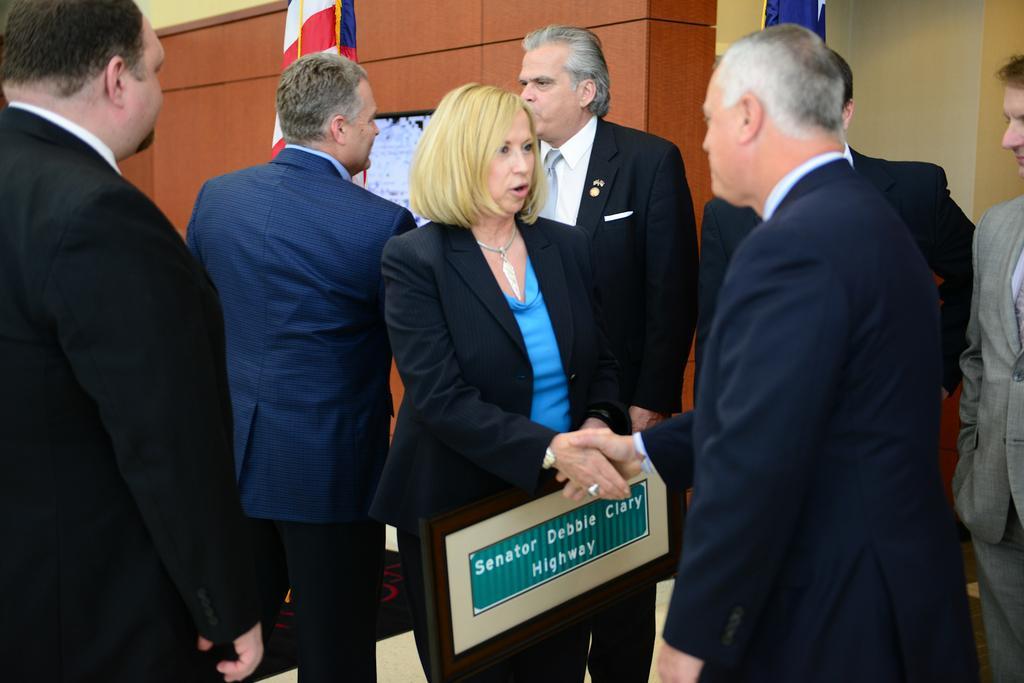In one or two sentences, can you explain what this image depicts? In this picture we can see a group of people standing and a woman is holding a name board. Behind the people there are flags and an object on the wooden wall. 